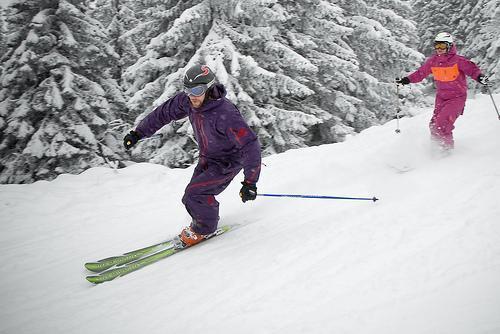How many people are in the picture?
Give a very brief answer. 2. 